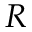<formula> <loc_0><loc_0><loc_500><loc_500>R</formula> 